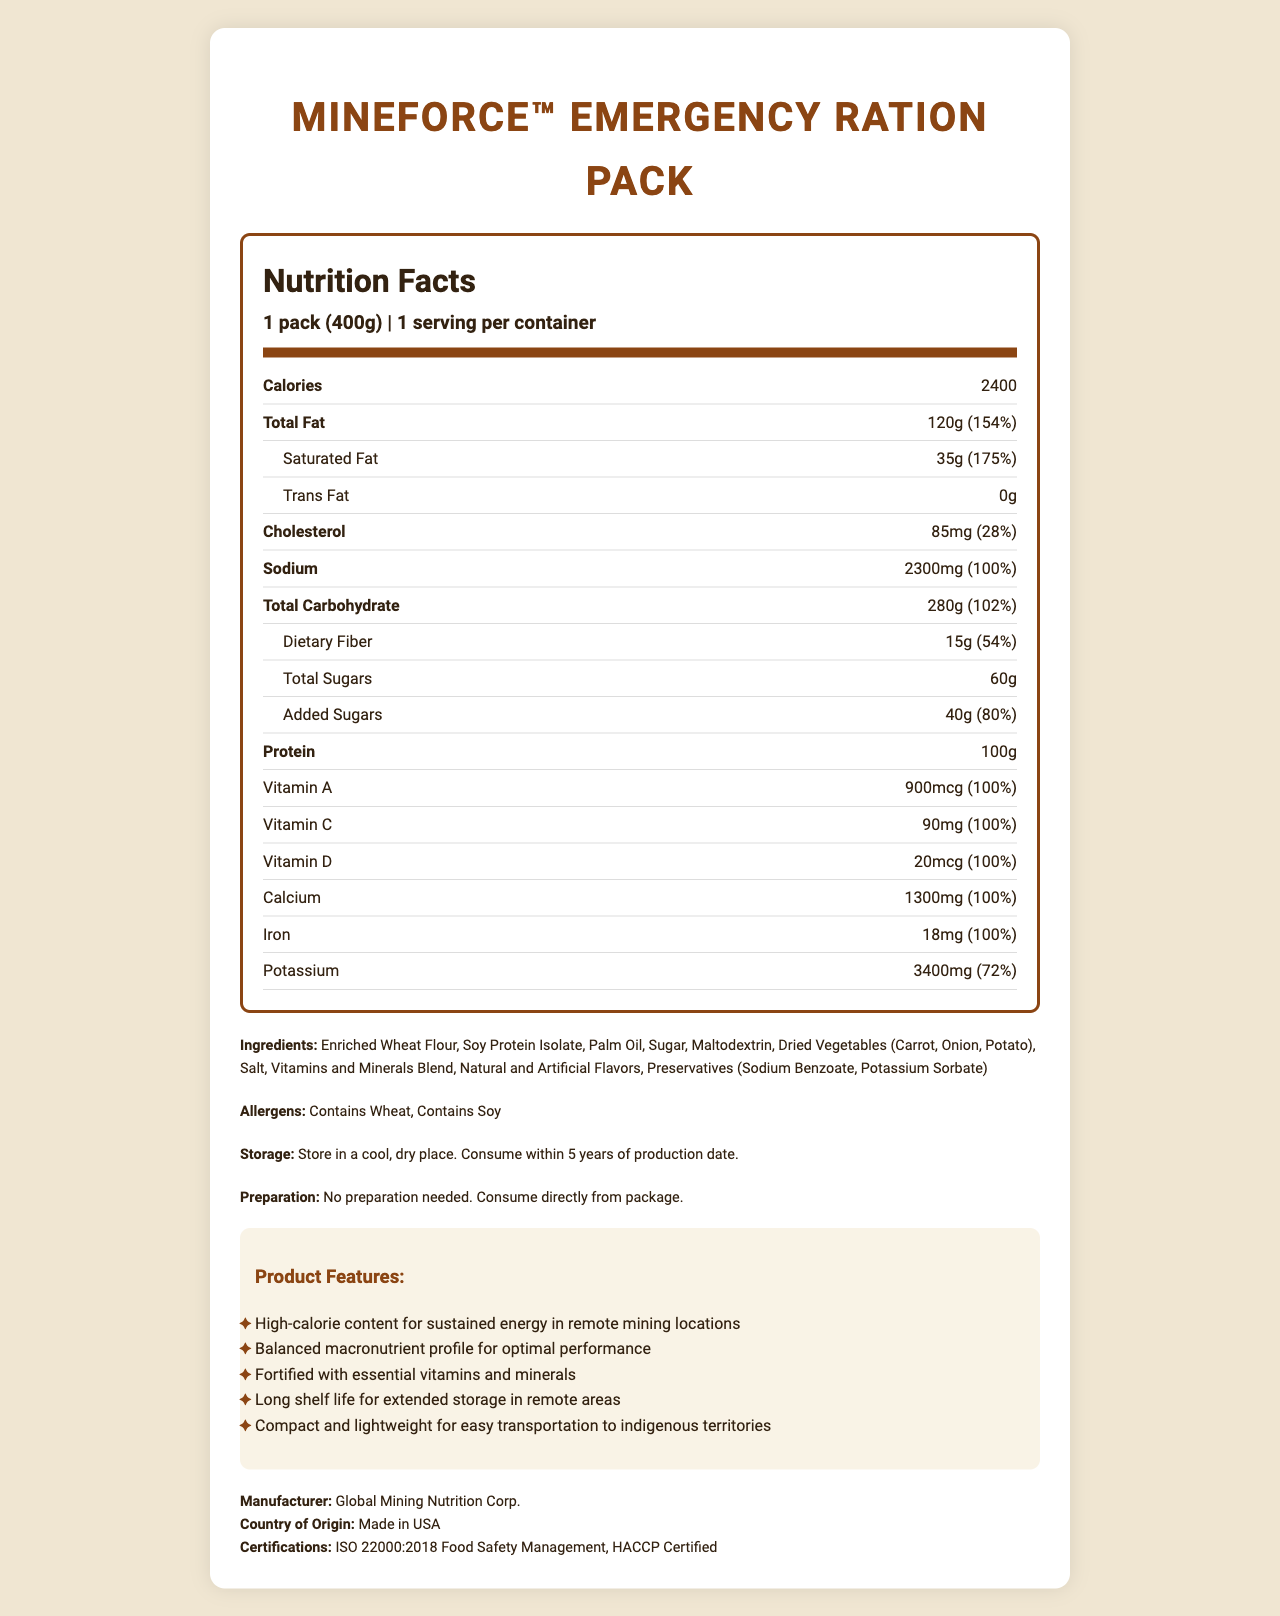What is the caloric content per serving of the MineForce™ Emergency Ration Pack? The document lists the caloric content under the nutrition facts section, showing that one pack, which is a single serving, contains 2400 calories.
Answer: 2400 calories How much protein does one pack of the MineForce™ Emergency Ration Pack provide? According to the nutrition facts, the protein content per serving size of the pack is 100 grams.
Answer: 100g What percentage of the daily value of protein is provided by one serving of the MineForce™ Emergency Ration Pack? The nutrition facts indicate that the pack contains 100 grams of protein, which is 200% of the daily value.
Answer: 200% Which of the following is an ingredient in the MineForce™ Emergency Ration Pack? A. High Fructose Corn Syrup B. Palm Oil C. Corn Starch The ingredient list includes “Palm Oil” as one of the components but does not mention high fructose corn syrup or corn starch.
Answer: B How long can the MineForce™ Emergency Ration Pack be stored? The storage instructions specify that the product should be consumed within 5 years of the production date.
Answer: 5 years Does the product contain any allergens? The allergens section in the document mentions that the product contains wheat and soy.
Answer: Yes Is the MineForce™ Emergency Ration Pack suitable for immediate consumption without preparation? The preparation instructions state that no preparation is needed and the product can be consumed directly from the package.
Answer: Yes What certifications does the MineForce™ Emergency Ration Pack hold? The document lists these certifications under the certifications section.
Answer: ISO 22000:2018 Food Safety Management, HACCP Certified Which feature of the MineForce™ Emergency Ration Pack is NOT mentioned in the product features? A. High-fat content for insulation B. High-calorie content for sustained energy C. Balanced macronutrient profile The document lists high-calorie content and balanced macronutrient profile but does not mention high-fat content for insulation.
Answer: A How much Vitamin C is in one serving of the MineForce™ Emergency Ration Pack? The nutrition facts specify that one serving contains 90 milligrams of Vitamin C.
Answer: 90mg Summarize the main idea of the MineForce™ Emergency Ration Pack's nutrition facts and features. The ration pack is detailed as a high-calorie, nutritious option for miners in remote locations, containing all necessary macronutrients and vitamins with convenient storage and preparation features.
Answer: The MineForce™ Emergency Ration Pack provides high-calorie, balanced nutrition with 2400 calories and 100g of protein per serving. It is designed for remote mining crews and contains essential vitamins and minerals. The rations have a long shelf life, are compact for easy transportation, and are fortified for optimal performance. It is made by Global Mining Nutrition Corp. with certifications for food safety. What is the percentage of daily value of sodium in one pack of the MineForce™ Emergency Ration Pack? The nutrition facts list sodium content as 2300 milligrams, which is 100% of the daily value.
Answer: 100% Is the total carbohydrate content higher or the protein content higher per serving? The document indicates that the total carbohydrate content is 280 grams per serving, while protein content is 100 grams per serving.
Answer: Total carbohydrate content Can the exact production date be determined from the document? While the storage instructions mention consuming within 5 years of production, the document does not provide the exact production date information.
Answer: Cannot be determined 